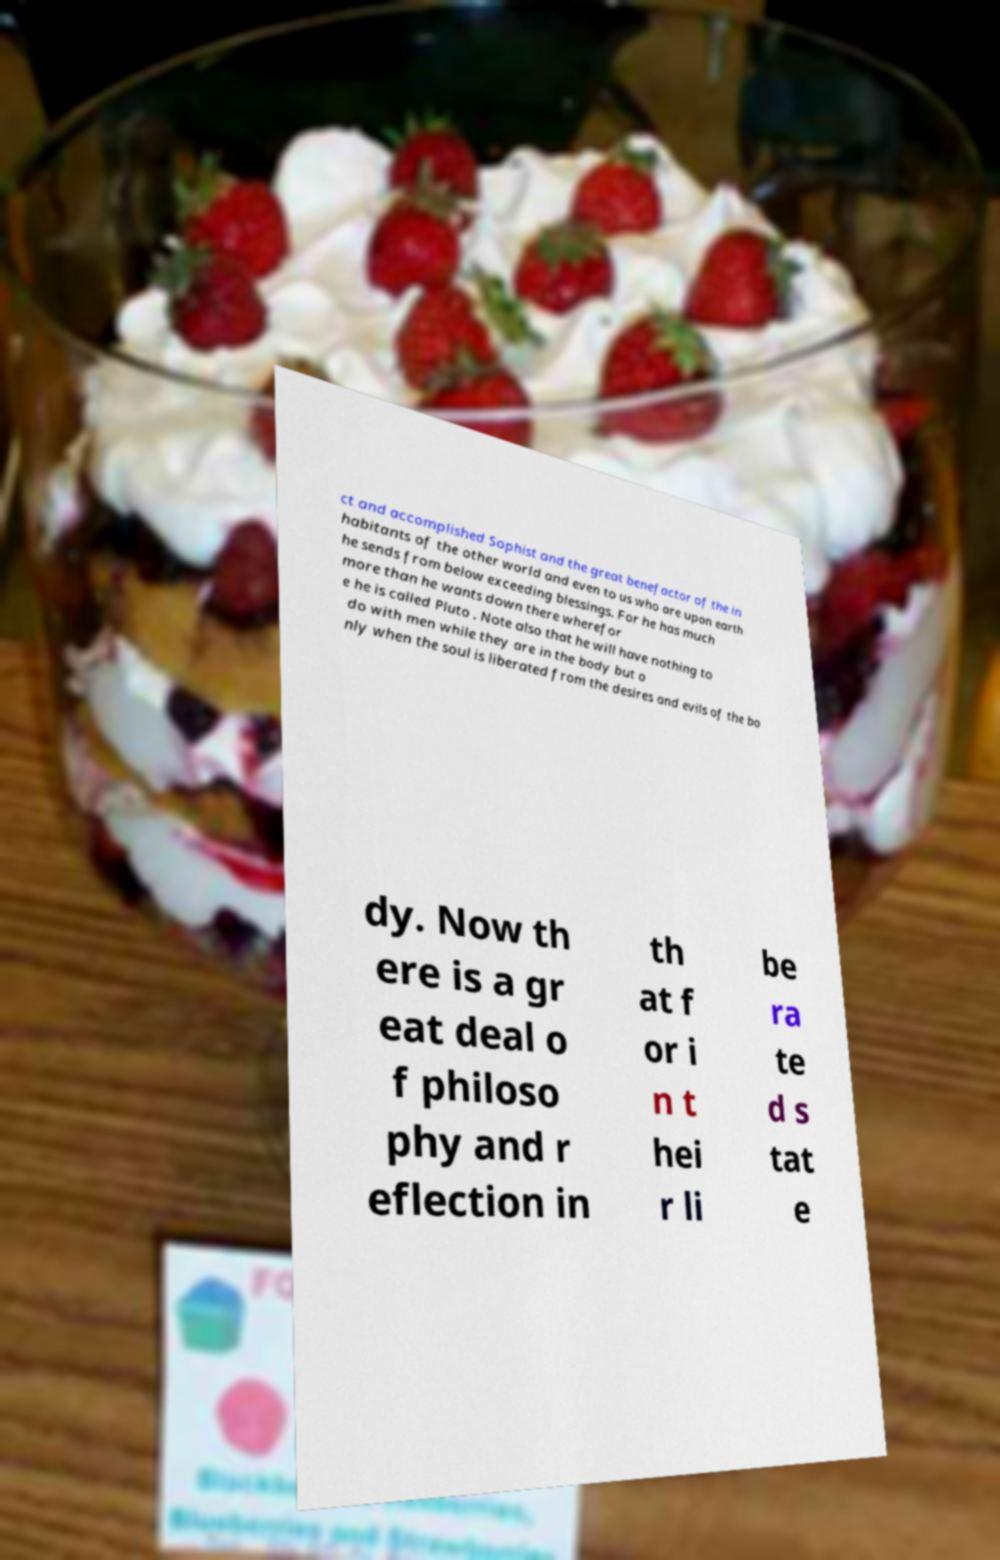Could you extract and type out the text from this image? ct and accomplished Sophist and the great benefactor of the in habitants of the other world and even to us who are upon earth he sends from below exceeding blessings. For he has much more than he wants down there wherefor e he is called Pluto . Note also that he will have nothing to do with men while they are in the body but o nly when the soul is liberated from the desires and evils of the bo dy. Now th ere is a gr eat deal o f philoso phy and r eflection in th at f or i n t hei r li be ra te d s tat e 